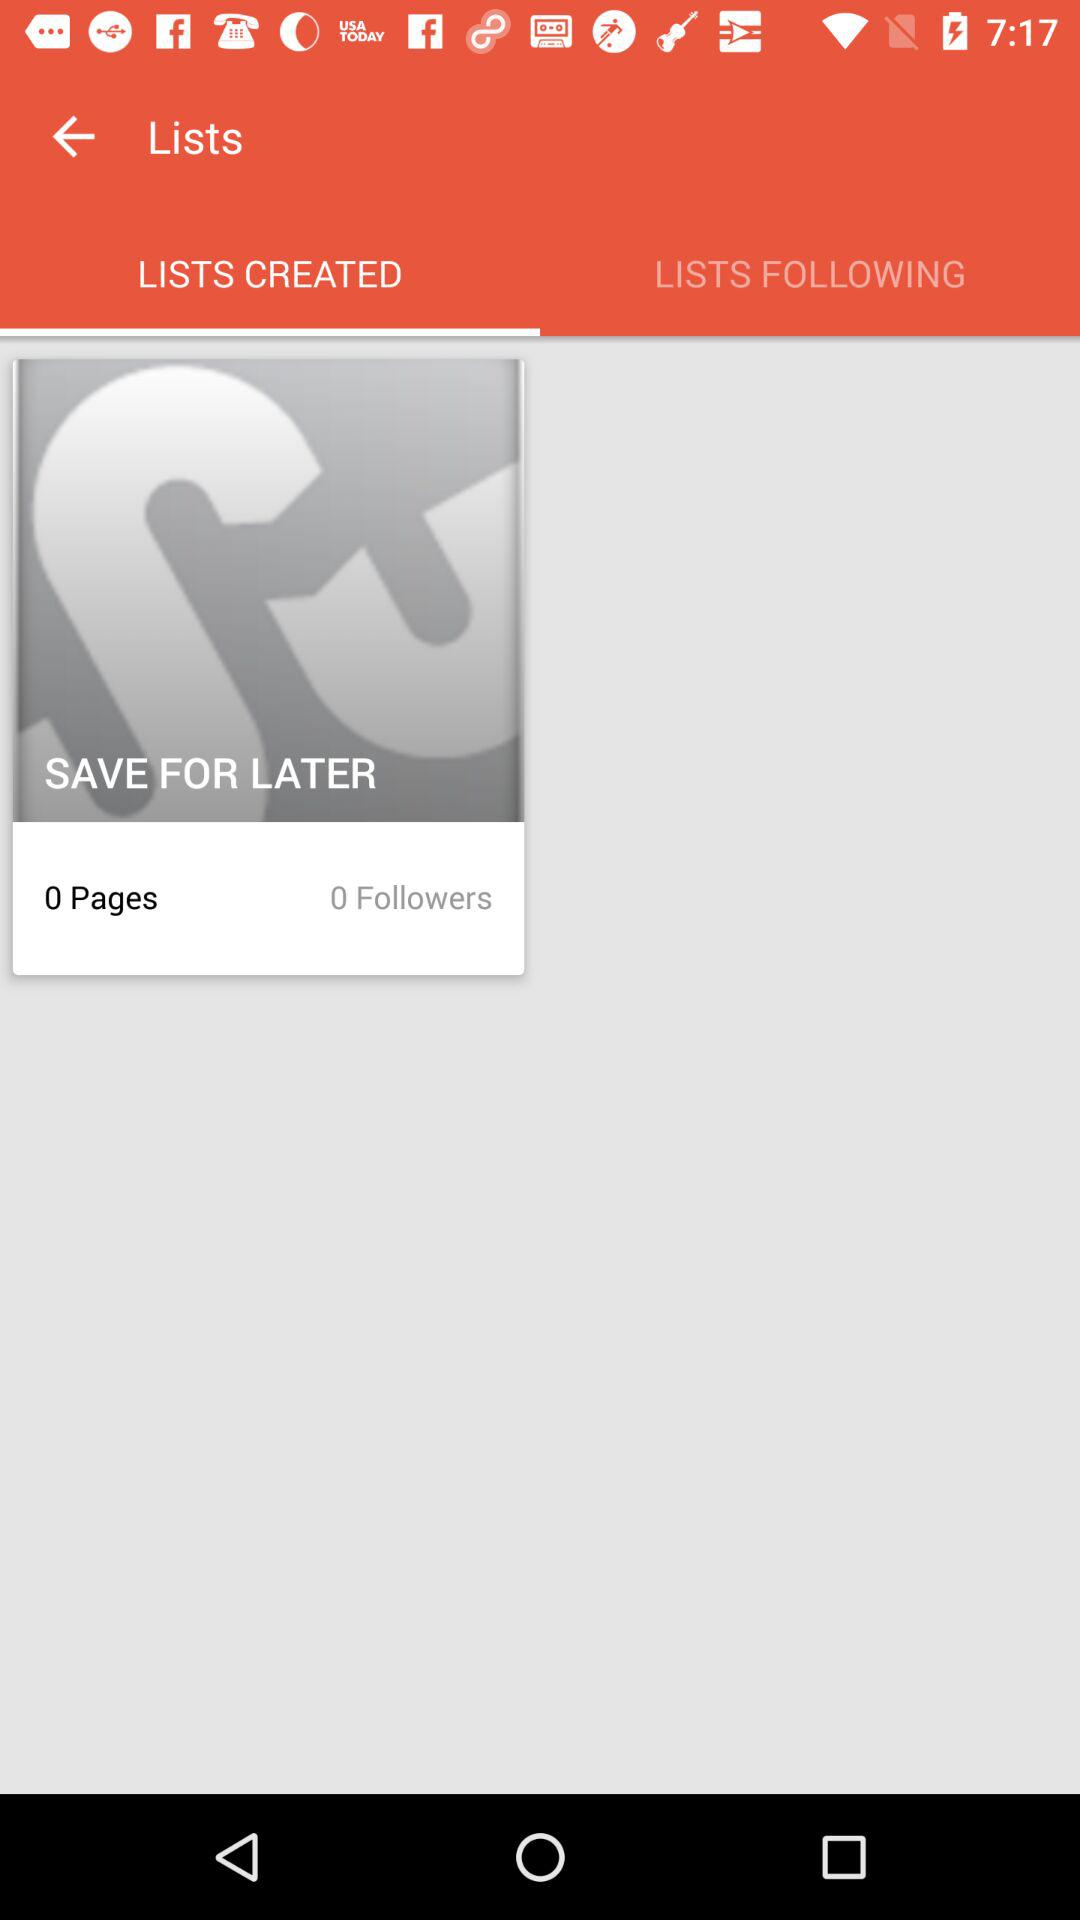Which tab has been selected? The tab that has been selected is "LISTS CREATED". 